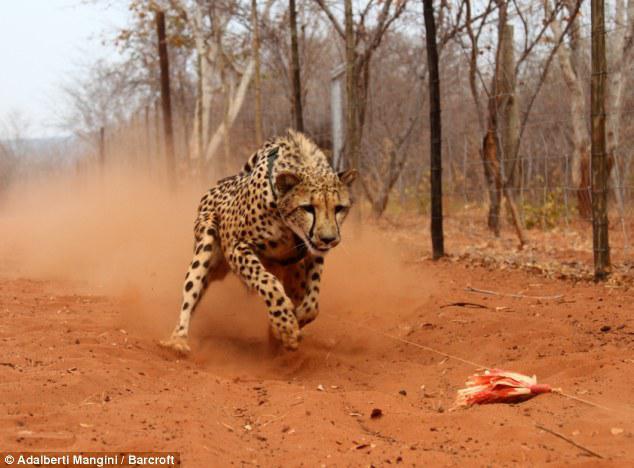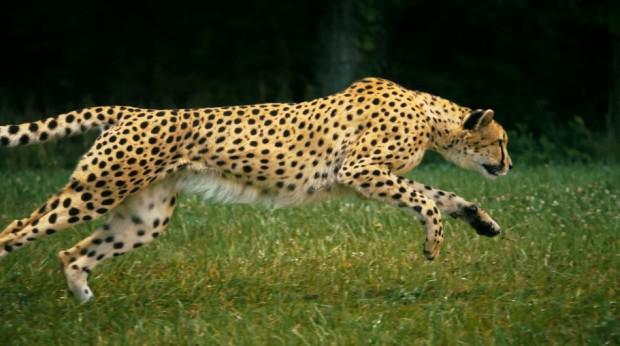The first image is the image on the left, the second image is the image on the right. Examine the images to the left and right. Is the description "Each image shows a cheetah in a running pose, and one image shows a cheetah bounding rightward over green grass." accurate? Answer yes or no. Yes. 